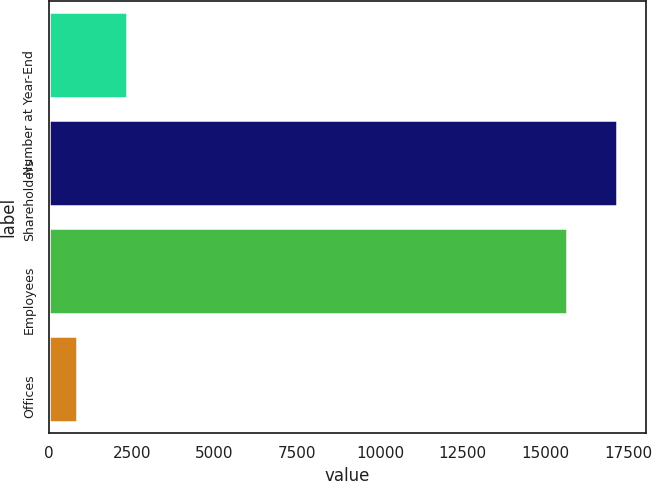Convert chart. <chart><loc_0><loc_0><loc_500><loc_500><bar_chart><fcel>Number at Year-End<fcel>Shareholders<fcel>Employees<fcel>Offices<nl><fcel>2360<fcel>17177<fcel>15666<fcel>849<nl></chart> 